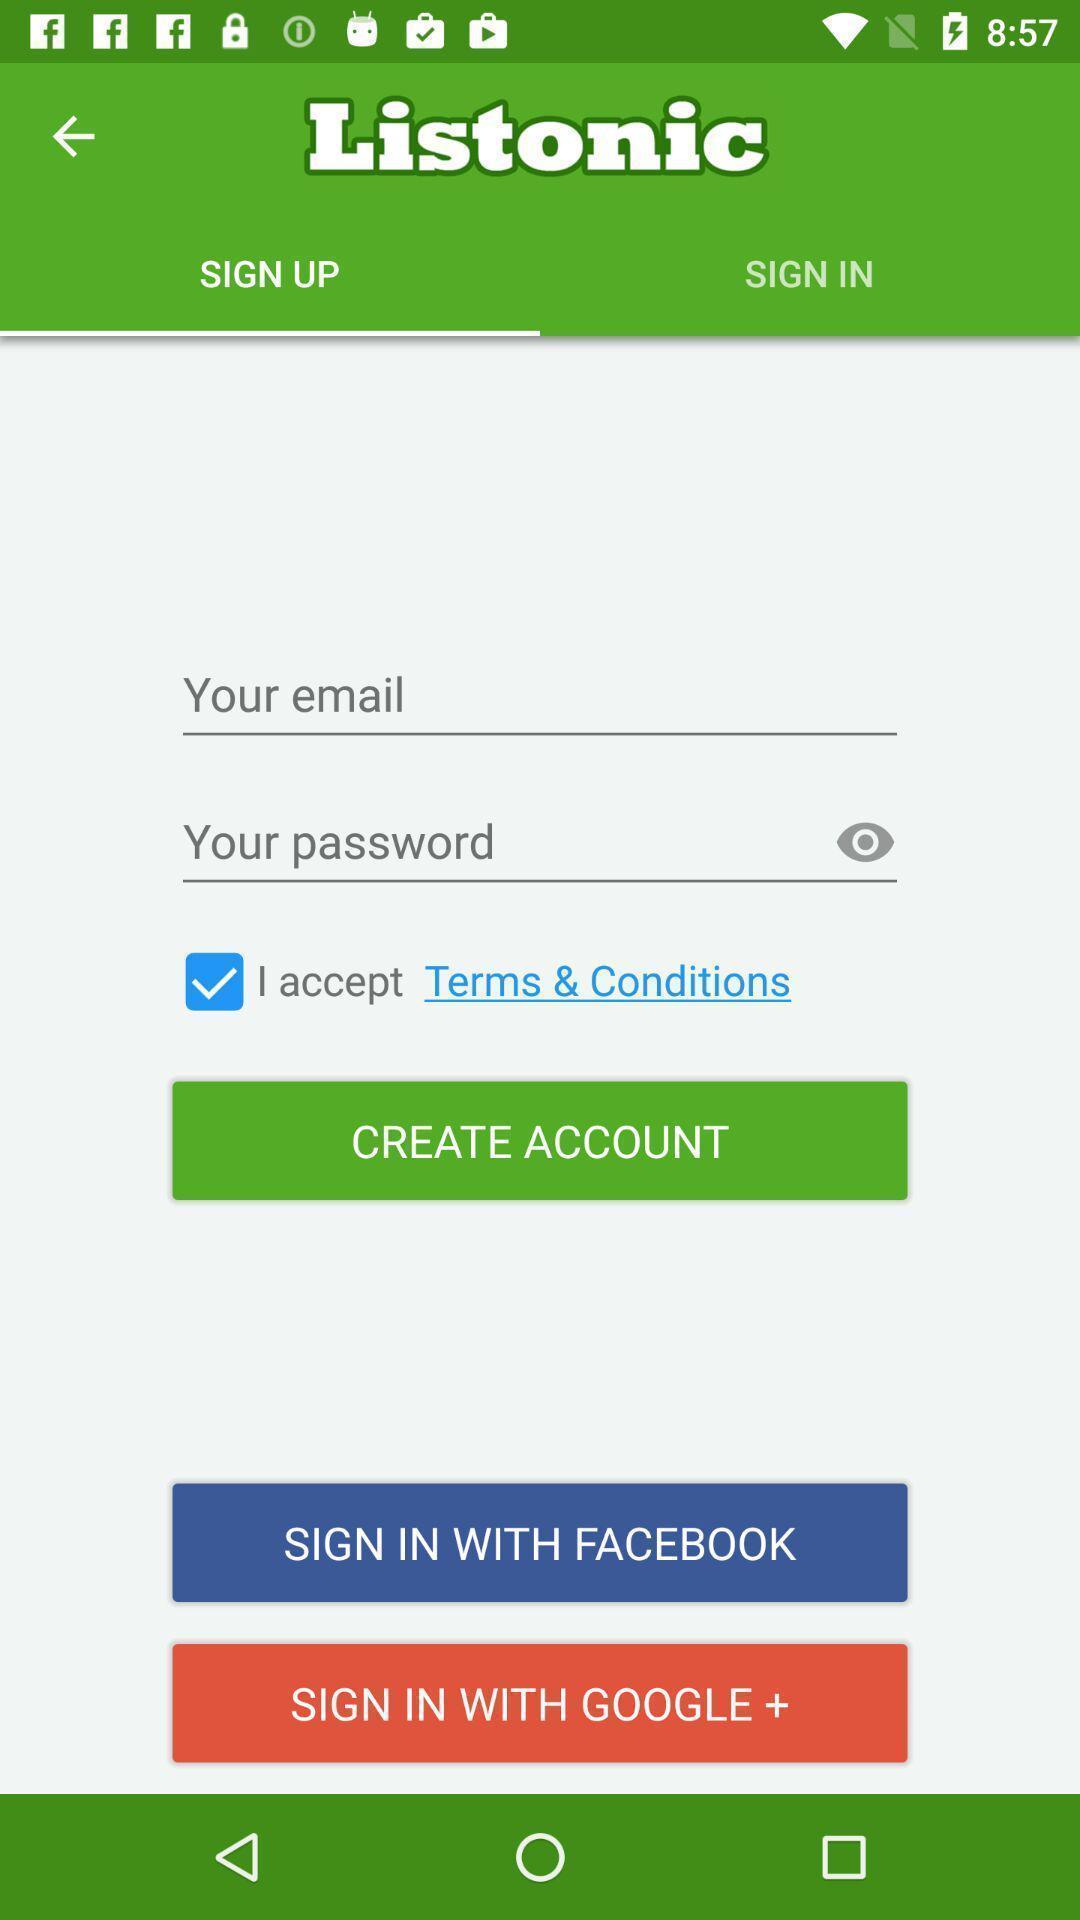Please provide a description for this image. Welcome page of grocery shopping app. 